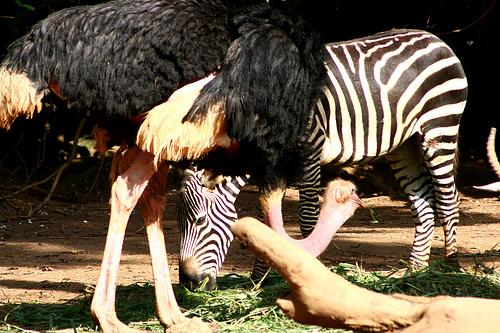What activity is happening in the image, specifically describing the grazing animal? The zebra is eating green grass, with its nose on the ground and muzzle appearing black and brown. Identify the setting in which the animals are located and any nearby objects. The ostrich and zebra are standing on green grass with a wooden trunk next to them. Choose a detail you would mention if you wanted to intrigue people in advertising the image. Capture the attention of your audience with a striking photo of a zebra behind an ostrich, both displaying vivid colors and detailed features on a grassy landscape. What three prominent features can be used to recognize the ostrich in the image? The ostrich has a pink neck, brown tail, and an orange nose. Compose a sentence that emphasizes the colors of the animals if you want to attract the attention of the viewers. Immerse yourself in this colorful scene featuring a zebra with black and white stripes accompanied by an ostrich with a pink neck, brown tail, and orange nose. Identify the primary subjects in the image and explain how they are interacting. An ostrich and a zebra are standing next to each other on a grassy area, with the ostrich hovering over the zebra and the zebra grazing on the grass. Describe the ground where the animals are standing, giving details about its surface and any shadows. The ostrich and zebra are standing on a grassy area that is mostly covered by dirt, with shadows visible on the ground. Describe the composition of the image in a way that makes it an attractive product advertisement. Showcase nature's beauty and diversity with this stunning image of an ostrich and a zebra sharing a moment in their vibrant, green grassy habitat. What color is the neck of the ostrich and what makes it interesting for the viewers? The ostrich has a pink neck that is curved, adding a unique and captivating visual element to the image. If you want to promote the curiosity of the viewer, what would you mention about the animal with the long neck? Capture the fascination of onlookers with a close-up of the curious ostrich's head and its gracefully curved, pink neck. 